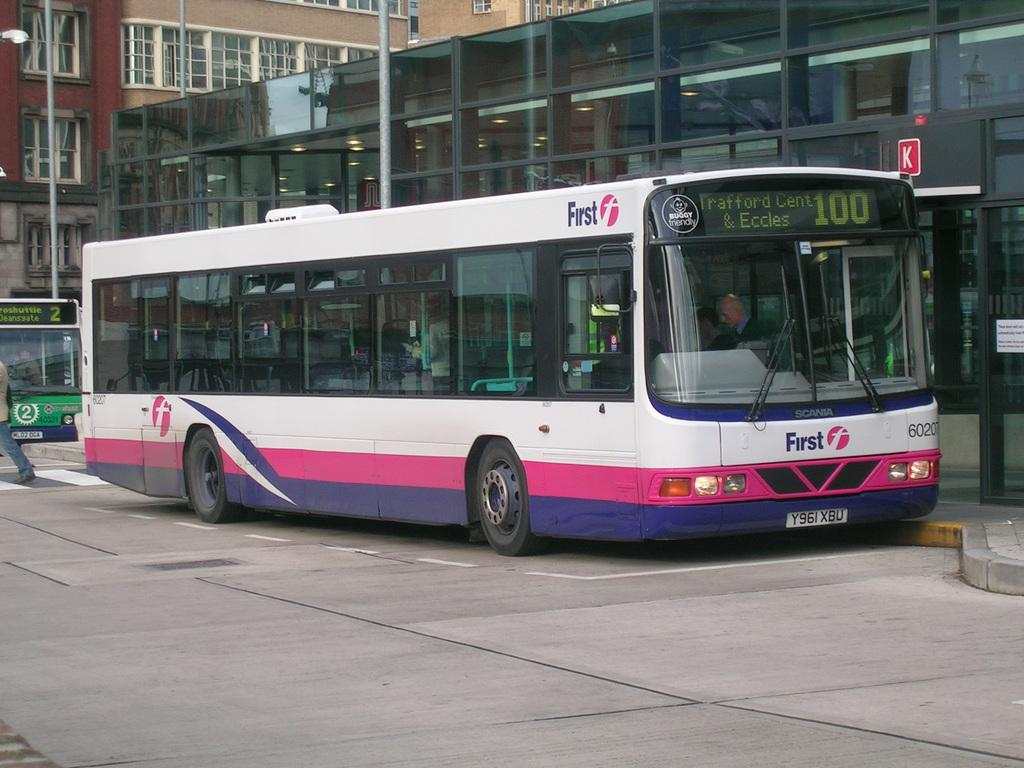What is the main subject of the image? There is a bus in the image. Where is the bus located in the image? The bus is on the side of the road. What can be seen in the background of the image? There are buildings visible behind the bus. How does the sock increase the speed of the bus in the image? There is no sock present in the image, and therefore it cannot affect the speed of the bus. 